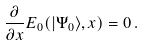<formula> <loc_0><loc_0><loc_500><loc_500>\frac { \partial } { \partial x } E _ { 0 } ( | \Psi _ { 0 } \rangle , x ) = 0 \, .</formula> 